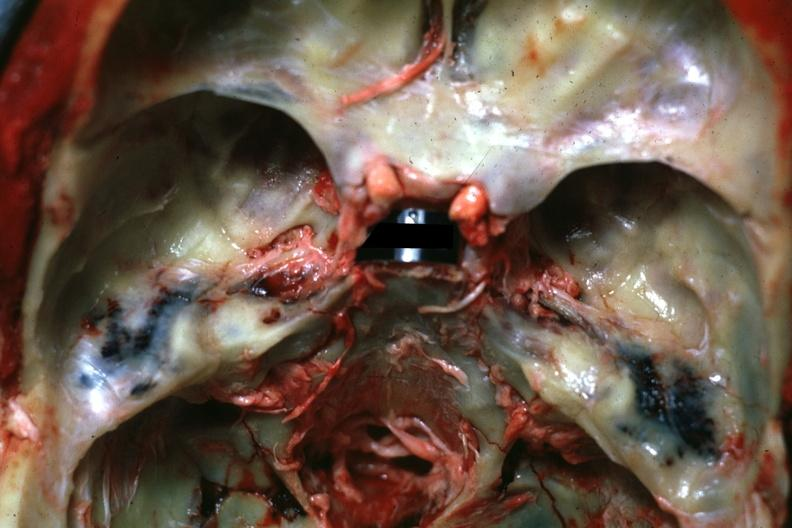s basilar skull fracture present?
Answer the question using a single word or phrase. Yes 